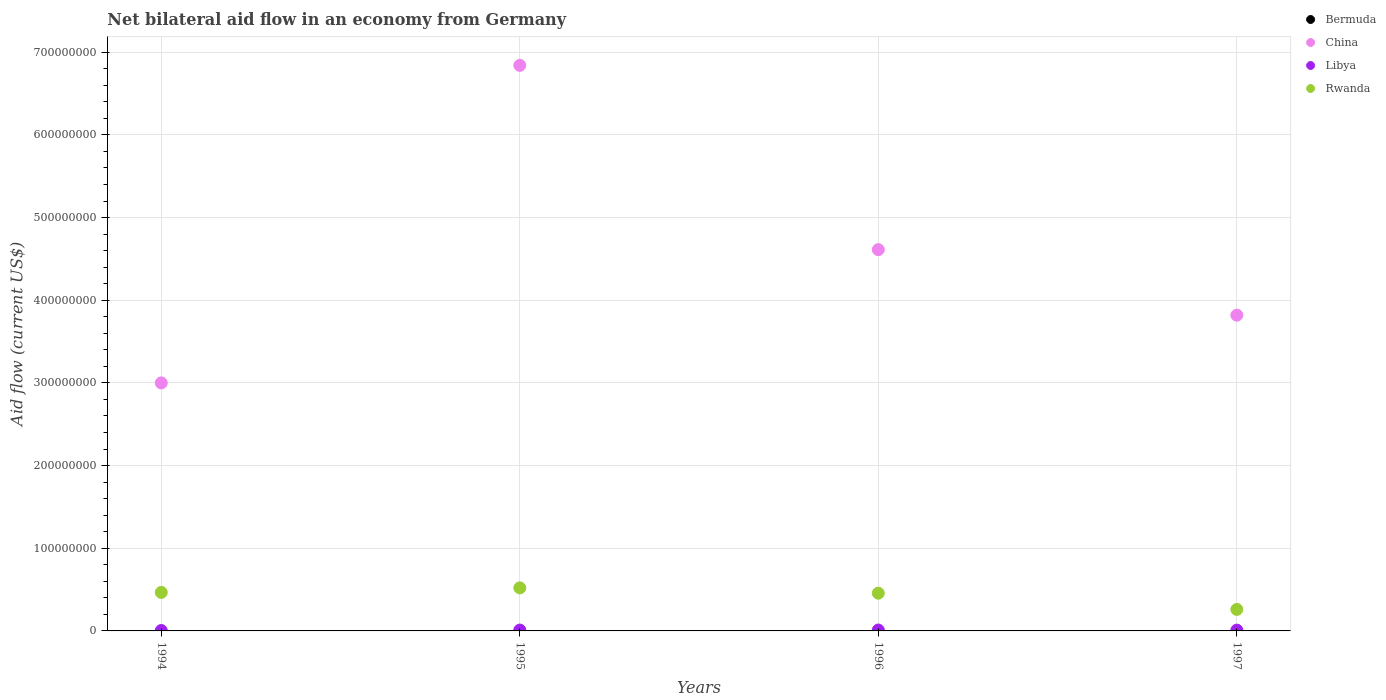Is the number of dotlines equal to the number of legend labels?
Make the answer very short. No. What is the net bilateral aid flow in Libya in 1994?
Offer a very short reply. 5.10e+05. Across all years, what is the maximum net bilateral aid flow in Rwanda?
Keep it short and to the point. 5.21e+07. Across all years, what is the minimum net bilateral aid flow in China?
Your answer should be very brief. 3.00e+08. In which year was the net bilateral aid flow in Libya maximum?
Give a very brief answer. 1996. What is the total net bilateral aid flow in China in the graph?
Give a very brief answer. 1.83e+09. What is the difference between the net bilateral aid flow in Libya in 1994 and that in 1995?
Make the answer very short. -5.30e+05. What is the difference between the net bilateral aid flow in Rwanda in 1995 and the net bilateral aid flow in Bermuda in 1997?
Make the answer very short. 5.21e+07. What is the average net bilateral aid flow in China per year?
Your response must be concise. 4.57e+08. In the year 1997, what is the difference between the net bilateral aid flow in Rwanda and net bilateral aid flow in China?
Offer a terse response. -3.56e+08. In how many years, is the net bilateral aid flow in Libya greater than 560000000 US$?
Offer a very short reply. 0. What is the ratio of the net bilateral aid flow in China in 1996 to that in 1997?
Keep it short and to the point. 1.21. Is the difference between the net bilateral aid flow in Rwanda in 1995 and 1997 greater than the difference between the net bilateral aid flow in China in 1995 and 1997?
Your answer should be very brief. No. What is the difference between the highest and the second highest net bilateral aid flow in Rwanda?
Make the answer very short. 5.49e+06. What is the difference between the highest and the lowest net bilateral aid flow in China?
Keep it short and to the point. 3.84e+08. In how many years, is the net bilateral aid flow in Rwanda greater than the average net bilateral aid flow in Rwanda taken over all years?
Your answer should be very brief. 3. Is the net bilateral aid flow in Rwanda strictly greater than the net bilateral aid flow in China over the years?
Provide a succinct answer. No. Is the net bilateral aid flow in Rwanda strictly less than the net bilateral aid flow in Libya over the years?
Offer a very short reply. No. How many dotlines are there?
Keep it short and to the point. 3. How many years are there in the graph?
Your response must be concise. 4. What is the difference between two consecutive major ticks on the Y-axis?
Keep it short and to the point. 1.00e+08. Are the values on the major ticks of Y-axis written in scientific E-notation?
Your response must be concise. No. Does the graph contain any zero values?
Make the answer very short. Yes. Does the graph contain grids?
Provide a short and direct response. Yes. Where does the legend appear in the graph?
Your response must be concise. Top right. How are the legend labels stacked?
Make the answer very short. Vertical. What is the title of the graph?
Your response must be concise. Net bilateral aid flow in an economy from Germany. Does "Solomon Islands" appear as one of the legend labels in the graph?
Ensure brevity in your answer.  No. What is the Aid flow (current US$) of Bermuda in 1994?
Your response must be concise. 0. What is the Aid flow (current US$) in China in 1994?
Ensure brevity in your answer.  3.00e+08. What is the Aid flow (current US$) in Libya in 1994?
Provide a succinct answer. 5.10e+05. What is the Aid flow (current US$) in Rwanda in 1994?
Provide a succinct answer. 4.66e+07. What is the Aid flow (current US$) in Bermuda in 1995?
Provide a short and direct response. 0. What is the Aid flow (current US$) in China in 1995?
Your response must be concise. 6.84e+08. What is the Aid flow (current US$) of Libya in 1995?
Your answer should be compact. 1.04e+06. What is the Aid flow (current US$) in Rwanda in 1995?
Provide a succinct answer. 5.21e+07. What is the Aid flow (current US$) in Bermuda in 1996?
Make the answer very short. 0. What is the Aid flow (current US$) in China in 1996?
Offer a very short reply. 4.61e+08. What is the Aid flow (current US$) in Libya in 1996?
Your response must be concise. 1.10e+06. What is the Aid flow (current US$) of Rwanda in 1996?
Provide a succinct answer. 4.56e+07. What is the Aid flow (current US$) of Bermuda in 1997?
Your answer should be compact. 0. What is the Aid flow (current US$) in China in 1997?
Ensure brevity in your answer.  3.82e+08. What is the Aid flow (current US$) in Libya in 1997?
Provide a short and direct response. 9.90e+05. What is the Aid flow (current US$) in Rwanda in 1997?
Keep it short and to the point. 2.60e+07. Across all years, what is the maximum Aid flow (current US$) in China?
Provide a short and direct response. 6.84e+08. Across all years, what is the maximum Aid flow (current US$) of Libya?
Give a very brief answer. 1.10e+06. Across all years, what is the maximum Aid flow (current US$) of Rwanda?
Give a very brief answer. 5.21e+07. Across all years, what is the minimum Aid flow (current US$) in China?
Your answer should be very brief. 3.00e+08. Across all years, what is the minimum Aid flow (current US$) in Libya?
Make the answer very short. 5.10e+05. Across all years, what is the minimum Aid flow (current US$) in Rwanda?
Provide a succinct answer. 2.60e+07. What is the total Aid flow (current US$) of Bermuda in the graph?
Offer a very short reply. 0. What is the total Aid flow (current US$) in China in the graph?
Your response must be concise. 1.83e+09. What is the total Aid flow (current US$) of Libya in the graph?
Provide a succinct answer. 3.64e+06. What is the total Aid flow (current US$) in Rwanda in the graph?
Your answer should be very brief. 1.70e+08. What is the difference between the Aid flow (current US$) of China in 1994 and that in 1995?
Ensure brevity in your answer.  -3.84e+08. What is the difference between the Aid flow (current US$) of Libya in 1994 and that in 1995?
Provide a short and direct response. -5.30e+05. What is the difference between the Aid flow (current US$) of Rwanda in 1994 and that in 1995?
Your answer should be compact. -5.49e+06. What is the difference between the Aid flow (current US$) of China in 1994 and that in 1996?
Provide a short and direct response. -1.61e+08. What is the difference between the Aid flow (current US$) of Libya in 1994 and that in 1996?
Ensure brevity in your answer.  -5.90e+05. What is the difference between the Aid flow (current US$) in Rwanda in 1994 and that in 1996?
Give a very brief answer. 9.30e+05. What is the difference between the Aid flow (current US$) in China in 1994 and that in 1997?
Provide a succinct answer. -8.19e+07. What is the difference between the Aid flow (current US$) in Libya in 1994 and that in 1997?
Offer a terse response. -4.80e+05. What is the difference between the Aid flow (current US$) of Rwanda in 1994 and that in 1997?
Offer a terse response. 2.06e+07. What is the difference between the Aid flow (current US$) of China in 1995 and that in 1996?
Your answer should be compact. 2.23e+08. What is the difference between the Aid flow (current US$) in Rwanda in 1995 and that in 1996?
Provide a short and direct response. 6.42e+06. What is the difference between the Aid flow (current US$) in China in 1995 and that in 1997?
Ensure brevity in your answer.  3.02e+08. What is the difference between the Aid flow (current US$) of Rwanda in 1995 and that in 1997?
Offer a terse response. 2.61e+07. What is the difference between the Aid flow (current US$) in China in 1996 and that in 1997?
Your answer should be very brief. 7.92e+07. What is the difference between the Aid flow (current US$) of Rwanda in 1996 and that in 1997?
Make the answer very short. 1.96e+07. What is the difference between the Aid flow (current US$) in China in 1994 and the Aid flow (current US$) in Libya in 1995?
Ensure brevity in your answer.  2.99e+08. What is the difference between the Aid flow (current US$) of China in 1994 and the Aid flow (current US$) of Rwanda in 1995?
Make the answer very short. 2.48e+08. What is the difference between the Aid flow (current US$) in Libya in 1994 and the Aid flow (current US$) in Rwanda in 1995?
Offer a very short reply. -5.16e+07. What is the difference between the Aid flow (current US$) of China in 1994 and the Aid flow (current US$) of Libya in 1996?
Make the answer very short. 2.99e+08. What is the difference between the Aid flow (current US$) in China in 1994 and the Aid flow (current US$) in Rwanda in 1996?
Ensure brevity in your answer.  2.54e+08. What is the difference between the Aid flow (current US$) of Libya in 1994 and the Aid flow (current US$) of Rwanda in 1996?
Your answer should be compact. -4.51e+07. What is the difference between the Aid flow (current US$) in China in 1994 and the Aid flow (current US$) in Libya in 1997?
Your answer should be compact. 2.99e+08. What is the difference between the Aid flow (current US$) of China in 1994 and the Aid flow (current US$) of Rwanda in 1997?
Offer a terse response. 2.74e+08. What is the difference between the Aid flow (current US$) of Libya in 1994 and the Aid flow (current US$) of Rwanda in 1997?
Your response must be concise. -2.55e+07. What is the difference between the Aid flow (current US$) in China in 1995 and the Aid flow (current US$) in Libya in 1996?
Your answer should be compact. 6.83e+08. What is the difference between the Aid flow (current US$) of China in 1995 and the Aid flow (current US$) of Rwanda in 1996?
Provide a short and direct response. 6.38e+08. What is the difference between the Aid flow (current US$) of Libya in 1995 and the Aid flow (current US$) of Rwanda in 1996?
Your answer should be very brief. -4.46e+07. What is the difference between the Aid flow (current US$) in China in 1995 and the Aid flow (current US$) in Libya in 1997?
Keep it short and to the point. 6.83e+08. What is the difference between the Aid flow (current US$) in China in 1995 and the Aid flow (current US$) in Rwanda in 1997?
Ensure brevity in your answer.  6.58e+08. What is the difference between the Aid flow (current US$) in Libya in 1995 and the Aid flow (current US$) in Rwanda in 1997?
Your answer should be compact. -2.50e+07. What is the difference between the Aid flow (current US$) of China in 1996 and the Aid flow (current US$) of Libya in 1997?
Give a very brief answer. 4.60e+08. What is the difference between the Aid flow (current US$) of China in 1996 and the Aid flow (current US$) of Rwanda in 1997?
Offer a terse response. 4.35e+08. What is the difference between the Aid flow (current US$) in Libya in 1996 and the Aid flow (current US$) in Rwanda in 1997?
Keep it short and to the point. -2.49e+07. What is the average Aid flow (current US$) of China per year?
Make the answer very short. 4.57e+08. What is the average Aid flow (current US$) in Libya per year?
Ensure brevity in your answer.  9.10e+05. What is the average Aid flow (current US$) in Rwanda per year?
Provide a succinct answer. 4.26e+07. In the year 1994, what is the difference between the Aid flow (current US$) in China and Aid flow (current US$) in Libya?
Offer a very short reply. 2.99e+08. In the year 1994, what is the difference between the Aid flow (current US$) of China and Aid flow (current US$) of Rwanda?
Make the answer very short. 2.53e+08. In the year 1994, what is the difference between the Aid flow (current US$) in Libya and Aid flow (current US$) in Rwanda?
Keep it short and to the point. -4.61e+07. In the year 1995, what is the difference between the Aid flow (current US$) in China and Aid flow (current US$) in Libya?
Give a very brief answer. 6.83e+08. In the year 1995, what is the difference between the Aid flow (current US$) in China and Aid flow (current US$) in Rwanda?
Keep it short and to the point. 6.32e+08. In the year 1995, what is the difference between the Aid flow (current US$) of Libya and Aid flow (current US$) of Rwanda?
Ensure brevity in your answer.  -5.10e+07. In the year 1996, what is the difference between the Aid flow (current US$) in China and Aid flow (current US$) in Libya?
Ensure brevity in your answer.  4.60e+08. In the year 1996, what is the difference between the Aid flow (current US$) of China and Aid flow (current US$) of Rwanda?
Give a very brief answer. 4.16e+08. In the year 1996, what is the difference between the Aid flow (current US$) of Libya and Aid flow (current US$) of Rwanda?
Ensure brevity in your answer.  -4.45e+07. In the year 1997, what is the difference between the Aid flow (current US$) of China and Aid flow (current US$) of Libya?
Your answer should be very brief. 3.81e+08. In the year 1997, what is the difference between the Aid flow (current US$) in China and Aid flow (current US$) in Rwanda?
Your answer should be very brief. 3.56e+08. In the year 1997, what is the difference between the Aid flow (current US$) of Libya and Aid flow (current US$) of Rwanda?
Your response must be concise. -2.50e+07. What is the ratio of the Aid flow (current US$) of China in 1994 to that in 1995?
Ensure brevity in your answer.  0.44. What is the ratio of the Aid flow (current US$) in Libya in 1994 to that in 1995?
Provide a succinct answer. 0.49. What is the ratio of the Aid flow (current US$) in Rwanda in 1994 to that in 1995?
Offer a terse response. 0.89. What is the ratio of the Aid flow (current US$) of China in 1994 to that in 1996?
Ensure brevity in your answer.  0.65. What is the ratio of the Aid flow (current US$) in Libya in 1994 to that in 1996?
Your answer should be compact. 0.46. What is the ratio of the Aid flow (current US$) of Rwanda in 1994 to that in 1996?
Your response must be concise. 1.02. What is the ratio of the Aid flow (current US$) of China in 1994 to that in 1997?
Provide a short and direct response. 0.79. What is the ratio of the Aid flow (current US$) of Libya in 1994 to that in 1997?
Make the answer very short. 0.52. What is the ratio of the Aid flow (current US$) of Rwanda in 1994 to that in 1997?
Offer a terse response. 1.79. What is the ratio of the Aid flow (current US$) in China in 1995 to that in 1996?
Offer a very short reply. 1.48. What is the ratio of the Aid flow (current US$) of Libya in 1995 to that in 1996?
Ensure brevity in your answer.  0.95. What is the ratio of the Aid flow (current US$) in Rwanda in 1995 to that in 1996?
Provide a short and direct response. 1.14. What is the ratio of the Aid flow (current US$) of China in 1995 to that in 1997?
Give a very brief answer. 1.79. What is the ratio of the Aid flow (current US$) in Libya in 1995 to that in 1997?
Provide a succinct answer. 1.05. What is the ratio of the Aid flow (current US$) of Rwanda in 1995 to that in 1997?
Your response must be concise. 2. What is the ratio of the Aid flow (current US$) in China in 1996 to that in 1997?
Your answer should be very brief. 1.21. What is the ratio of the Aid flow (current US$) of Libya in 1996 to that in 1997?
Provide a short and direct response. 1.11. What is the ratio of the Aid flow (current US$) in Rwanda in 1996 to that in 1997?
Offer a terse response. 1.76. What is the difference between the highest and the second highest Aid flow (current US$) of China?
Provide a succinct answer. 2.23e+08. What is the difference between the highest and the second highest Aid flow (current US$) in Rwanda?
Your answer should be very brief. 5.49e+06. What is the difference between the highest and the lowest Aid flow (current US$) of China?
Offer a terse response. 3.84e+08. What is the difference between the highest and the lowest Aid flow (current US$) of Libya?
Keep it short and to the point. 5.90e+05. What is the difference between the highest and the lowest Aid flow (current US$) of Rwanda?
Make the answer very short. 2.61e+07. 